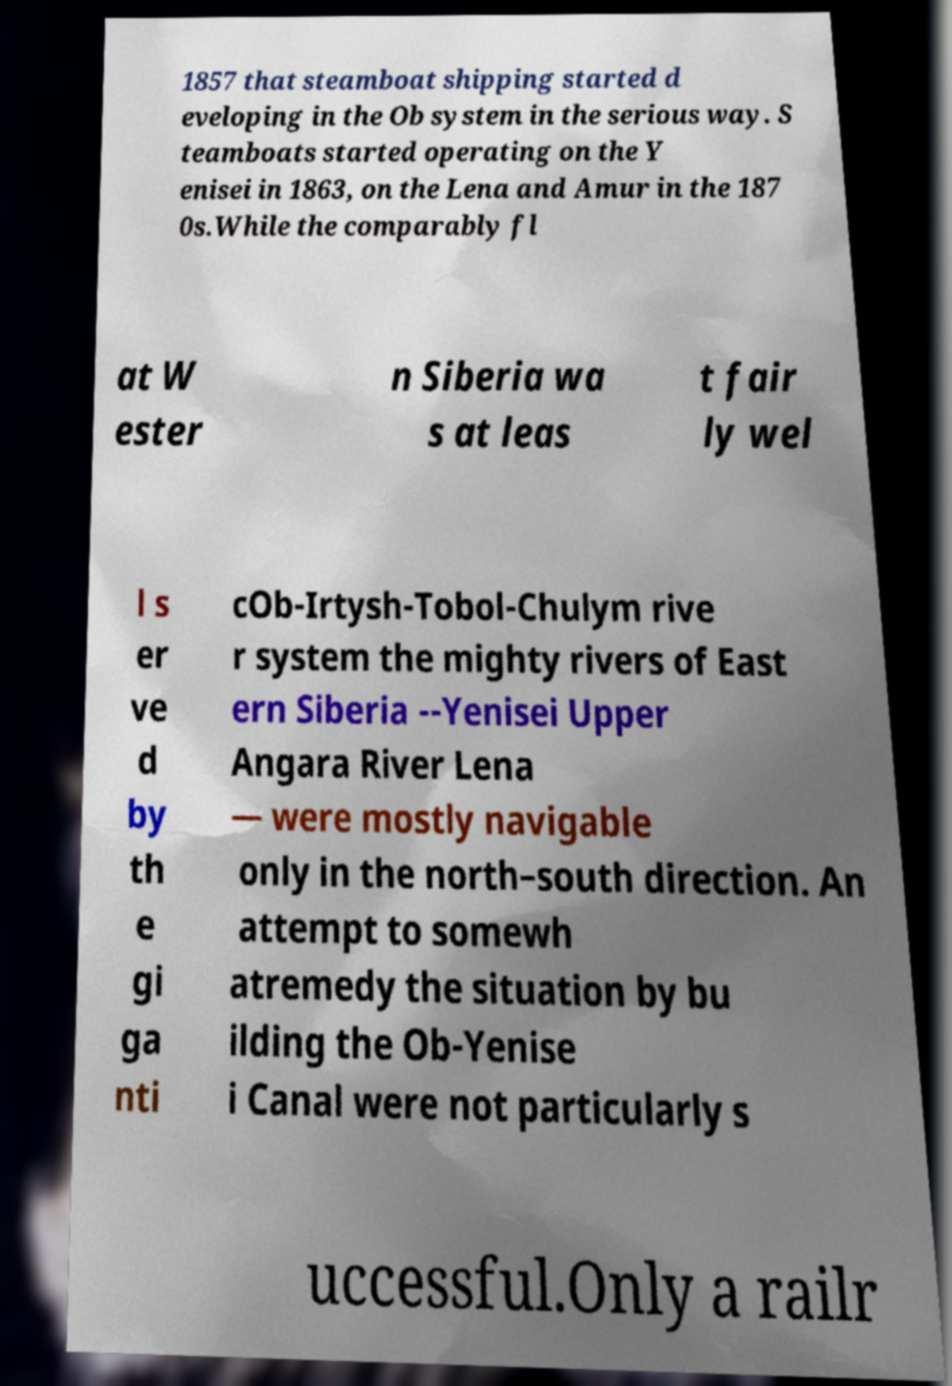Please read and relay the text visible in this image. What does it say? 1857 that steamboat shipping started d eveloping in the Ob system in the serious way. S teamboats started operating on the Y enisei in 1863, on the Lena and Amur in the 187 0s.While the comparably fl at W ester n Siberia wa s at leas t fair ly wel l s er ve d by th e gi ga nti cOb-Irtysh-Tobol-Chulym rive r system the mighty rivers of East ern Siberia --Yenisei Upper Angara River Lena — were mostly navigable only in the north–south direction. An attempt to somewh atremedy the situation by bu ilding the Ob-Yenise i Canal were not particularly s uccessful.Only a railr 